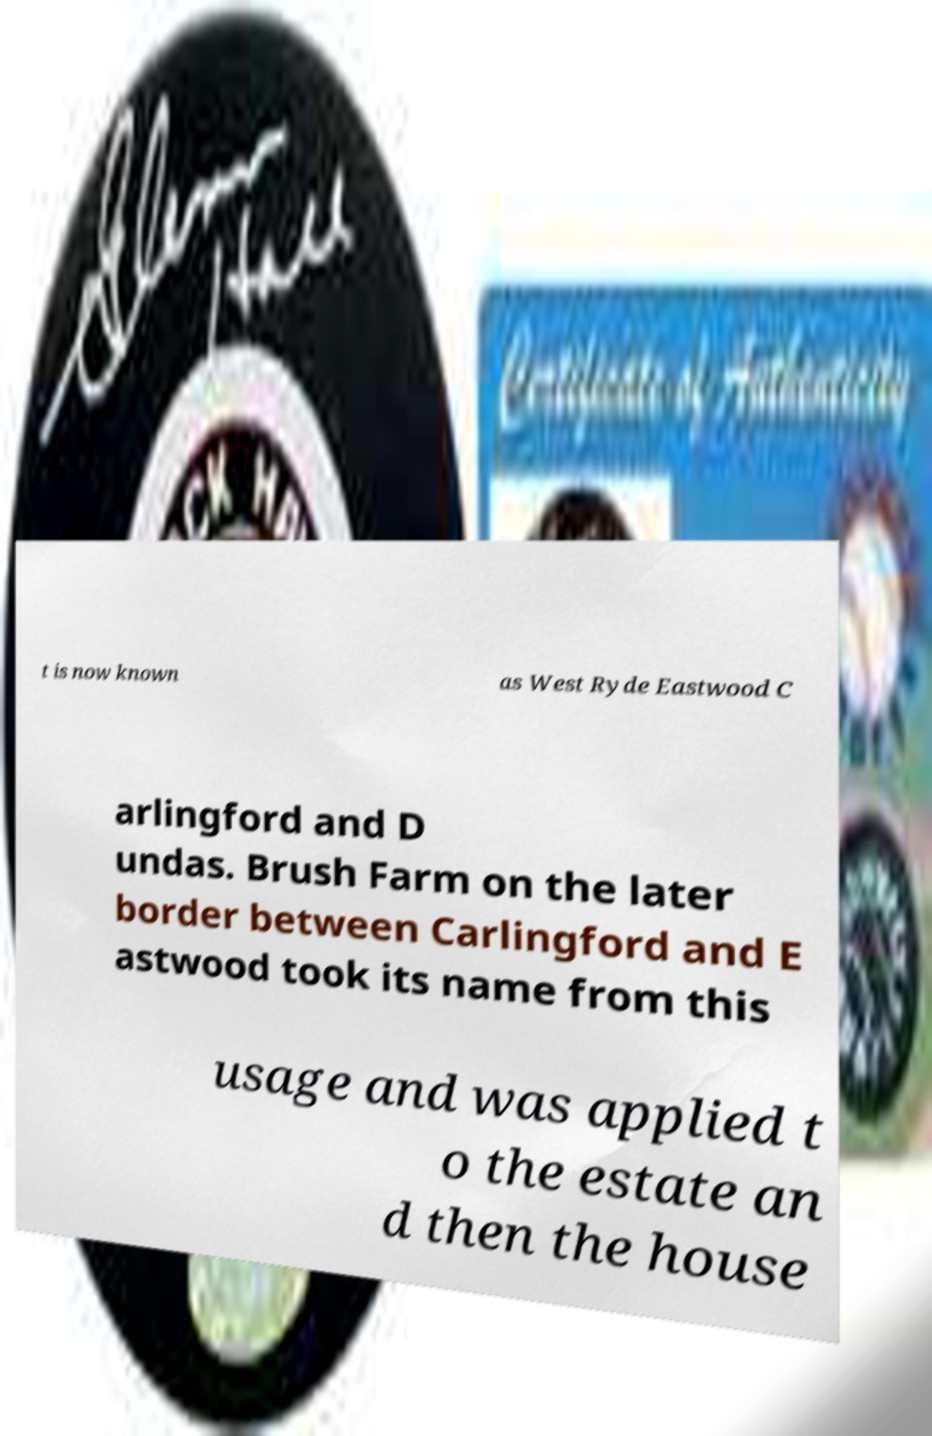Could you assist in decoding the text presented in this image and type it out clearly? t is now known as West Ryde Eastwood C arlingford and D undas. Brush Farm on the later border between Carlingford and E astwood took its name from this usage and was applied t o the estate an d then the house 